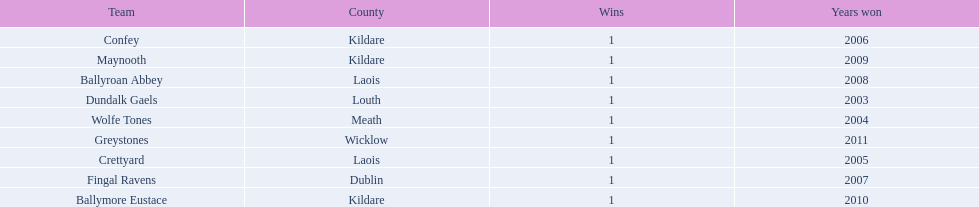Which team won previous to crettyard? Wolfe Tones. 